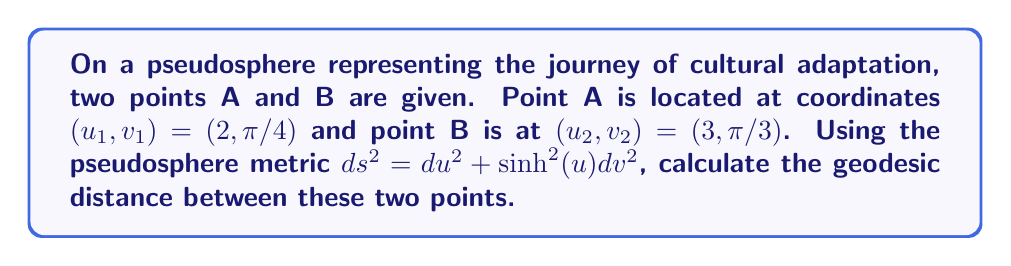Can you answer this question? To find the geodesic distance between two points on a pseudosphere, we need to use the following steps:

1. Recall the pseudosphere metric:
   $$ds^2 = du^2 + \sinh^2(u)dv^2$$

2. The geodesic distance is given by the integral:
   $$d = \int_{u_1}^{u_2} \sqrt{1 + \sinh^2(u)\left(\frac{dv}{du}\right)^2} du$$

3. We need to find $\frac{dv}{du}$. Given the two points:
   $(u_1, v_1) = (2, \pi/4)$ and $(u_2, v_2) = (3, \pi/3)$
   
   $$\frac{dv}{du} = \frac{v_2 - v_1}{u_2 - u_1} = \frac{\pi/3 - \pi/4}{3 - 2} = \frac{\pi}{12}$$

4. Substitute this into our integral:
   $$d = \int_2^3 \sqrt{1 + \sinh^2(u)\left(\frac{\pi}{12}\right)^2} du$$

5. This integral doesn't have a simple closed-form solution, so we need to use numerical integration methods to approximate it. Using a computational tool or numerical integration technique, we can evaluate this integral.

6. The result of this numerical integration is approximately 1.0307.

Therefore, the geodesic distance between points A and B on the pseudosphere is approximately 1.0307 units.
Answer: $1.0307$ (units) 